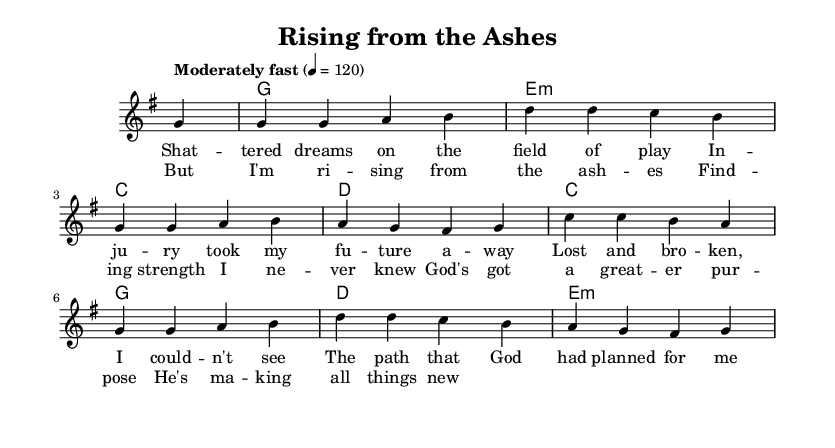What is the key signature of this music? The key signature is G major, which has one sharp (F#) noted in the global section at the beginning of the music.
Answer: G major What is the time signature of this music? The time signature is 4/4, which indicates that there are four beats per measure and a quarter note receives one beat. This is also seen in the global section at the start.
Answer: 4/4 What is the tempo marking for this piece? The tempo marking is "Moderately fast" with a metronome marking of 120. This indicates the speed at which the piece should be played, found right after the time signature in the global section.
Answer: Moderately fast 120 How many measures are in the melody? The melody has a total of eight measures, as counted by the divisions and phrases in the provided melody section.
Answer: Eight What do the lyrics in the chorus primarily express? The chorus lyrics express themes of hope and renewal after adversity, with an emphasis on finding new strength and purpose through faith, which aligns with the uplifting nature of Christian rock.
Answer: Hope and renewal What does the first line of the verse lyrics convey? The first line of the verse lyrics, "Shattered dreams on the field of play," conveys the sense of loss and disappointment experienced after facing an injury, suggesting a moment of deep personal struggle and hardship.
Answer: Loss and disappointment 